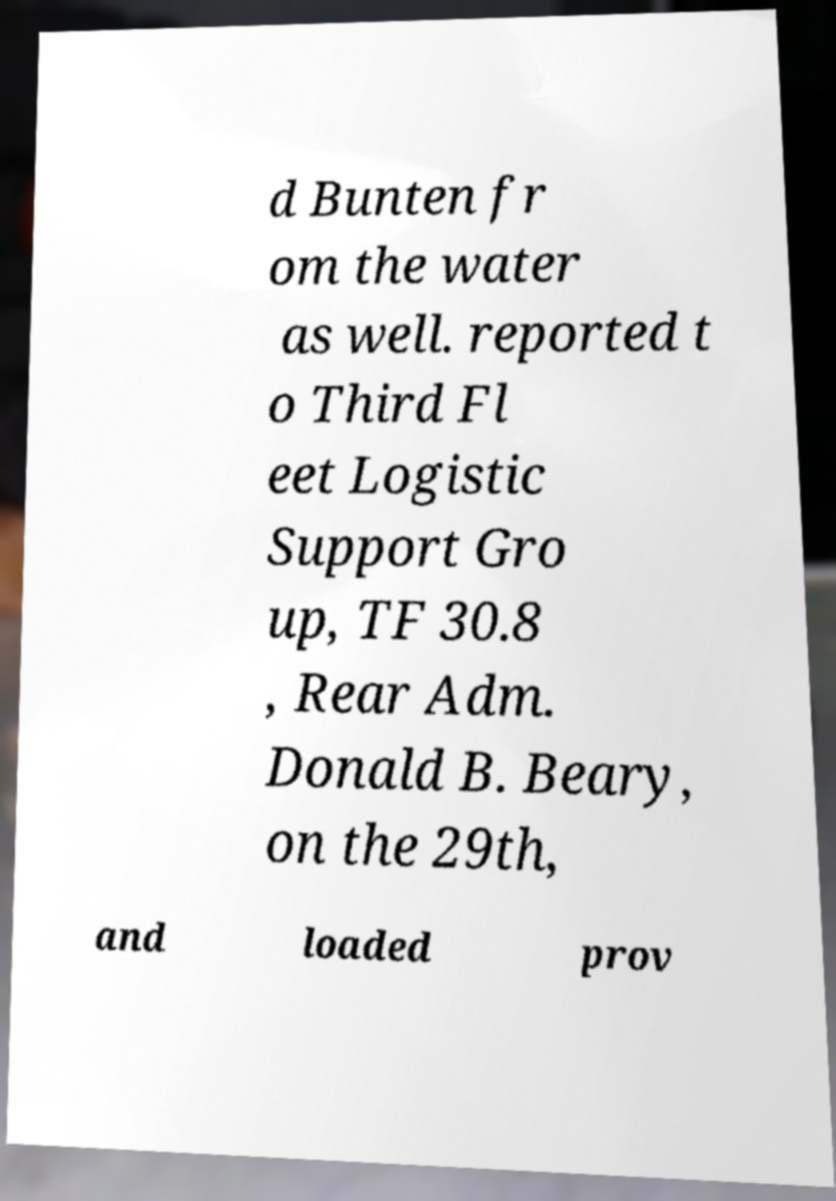Could you assist in decoding the text presented in this image and type it out clearly? d Bunten fr om the water as well. reported t o Third Fl eet Logistic Support Gro up, TF 30.8 , Rear Adm. Donald B. Beary, on the 29th, and loaded prov 